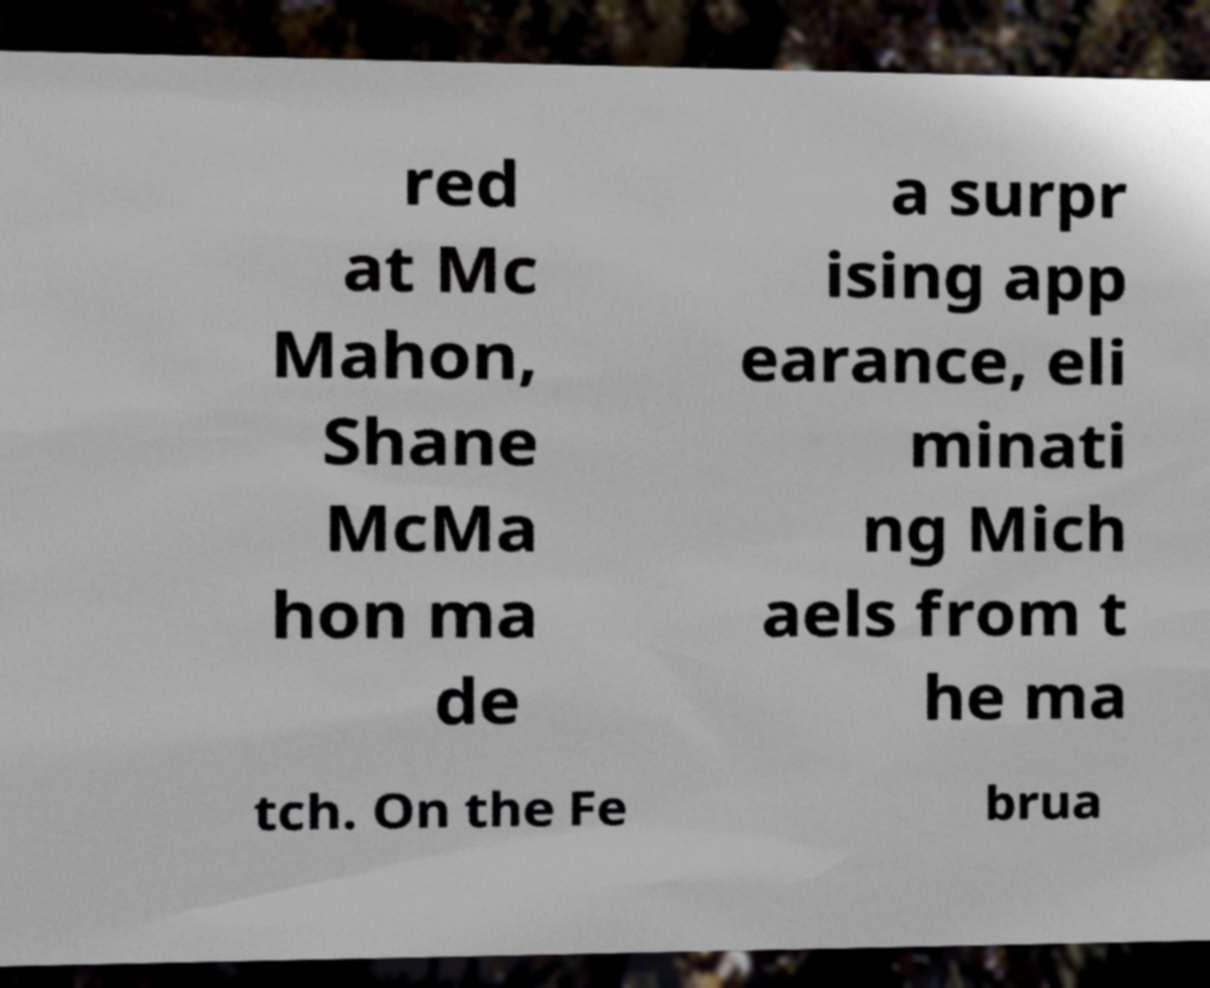There's text embedded in this image that I need extracted. Can you transcribe it verbatim? red at Mc Mahon, Shane McMa hon ma de a surpr ising app earance, eli minati ng Mich aels from t he ma tch. On the Fe brua 